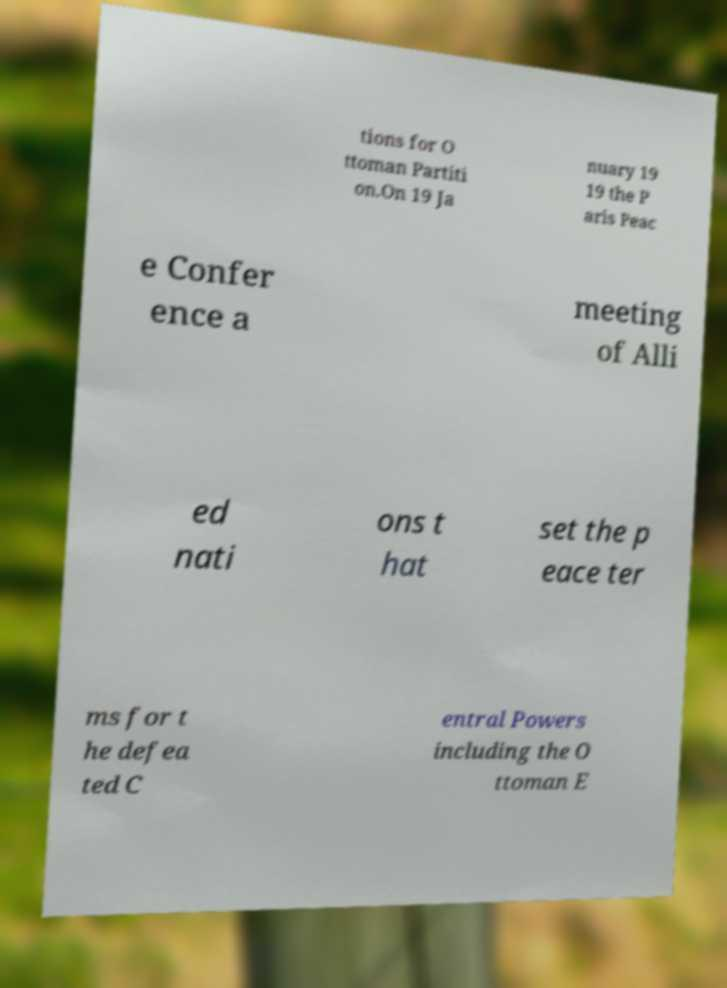For documentation purposes, I need the text within this image transcribed. Could you provide that? tions for O ttoman Partiti on.On 19 Ja nuary 19 19 the P aris Peac e Confer ence a meeting of Alli ed nati ons t hat set the p eace ter ms for t he defea ted C entral Powers including the O ttoman E 